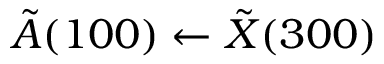<formula> <loc_0><loc_0><loc_500><loc_500>\tilde { A } ( 1 0 0 ) \leftarrow \tilde { X } ( 3 0 0 )</formula> 